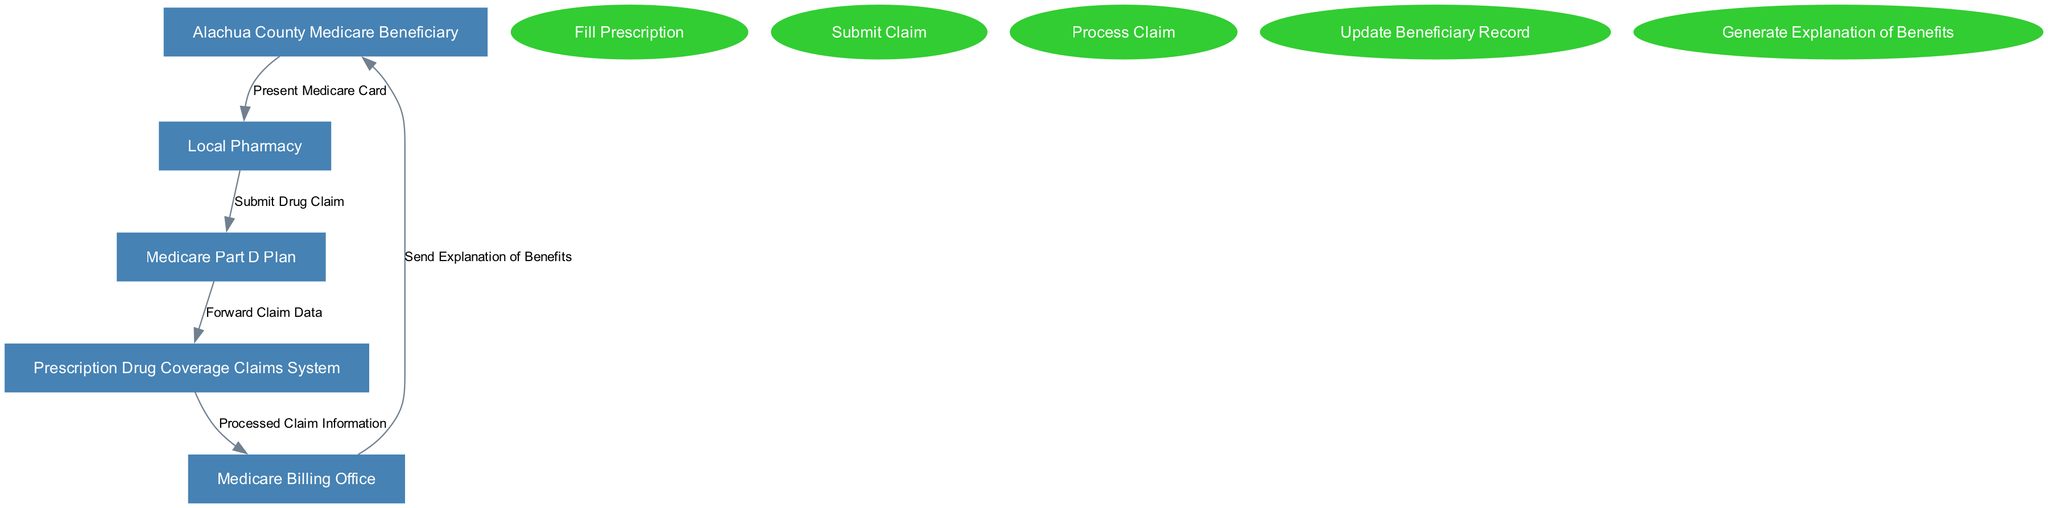What is the first step in the claim processing? The first step in the claim processing is "Fill Prescription", which is indicated as a process in the diagram, located before the subsequent steps.
Answer: Fill Prescription Who receives the drug claim from the local pharmacy? The local pharmacy submits the drug claim to the "Medicare Part D Plan," as shown by the flow direction indicated in the diagram.
Answer: Medicare Part D Plan How many entities are involved in the diagram? The diagram contains five entities, which are distinctly outlined within the entity section of the diagram.
Answer: Five What does the Medicare Billing Office send to the Medicare Beneficiary? The Medicare Billing Office sends an "Explanation of Benefits" to the Alachua County Medicare Beneficiary, which is depicted as a flow from the billing office to the beneficiary in the diagram.
Answer: Explanation of Benefits What process follows the submission of the drug claim? After the drug claim is submitted, the next process is "Process Claim," as indicated by the sequential flow of the diagram that outlines the order of operations.
Answer: Process Claim What is the final step in the claim processing flow? The final step is "Generate Explanation of Benefits", which is the last process shown in the claim processing sequence within the diagram.
Answer: Generate Explanation of Benefits What type of document is forwarded to the Prescription Drug Coverage Claims System? The document forwarded is "Claim Data," as indicated in the flow from the Medicare Part D Plan to the Prescription Drug Coverage Claims System.
Answer: Claim Data What relationship does the Alachua County Medicare Beneficiary have with the local pharmacy? The relationship is that the beneficiary presents the "Medicare Card" at the local pharmacy, which is indicated as the first flow connecting these two entities.
Answer: Present Medicare Card How many data flows are shown in the diagram? The diagram shows five data flows connecting the various entities and processes involved in the claim processing system, which can be counted visually.
Answer: Five 